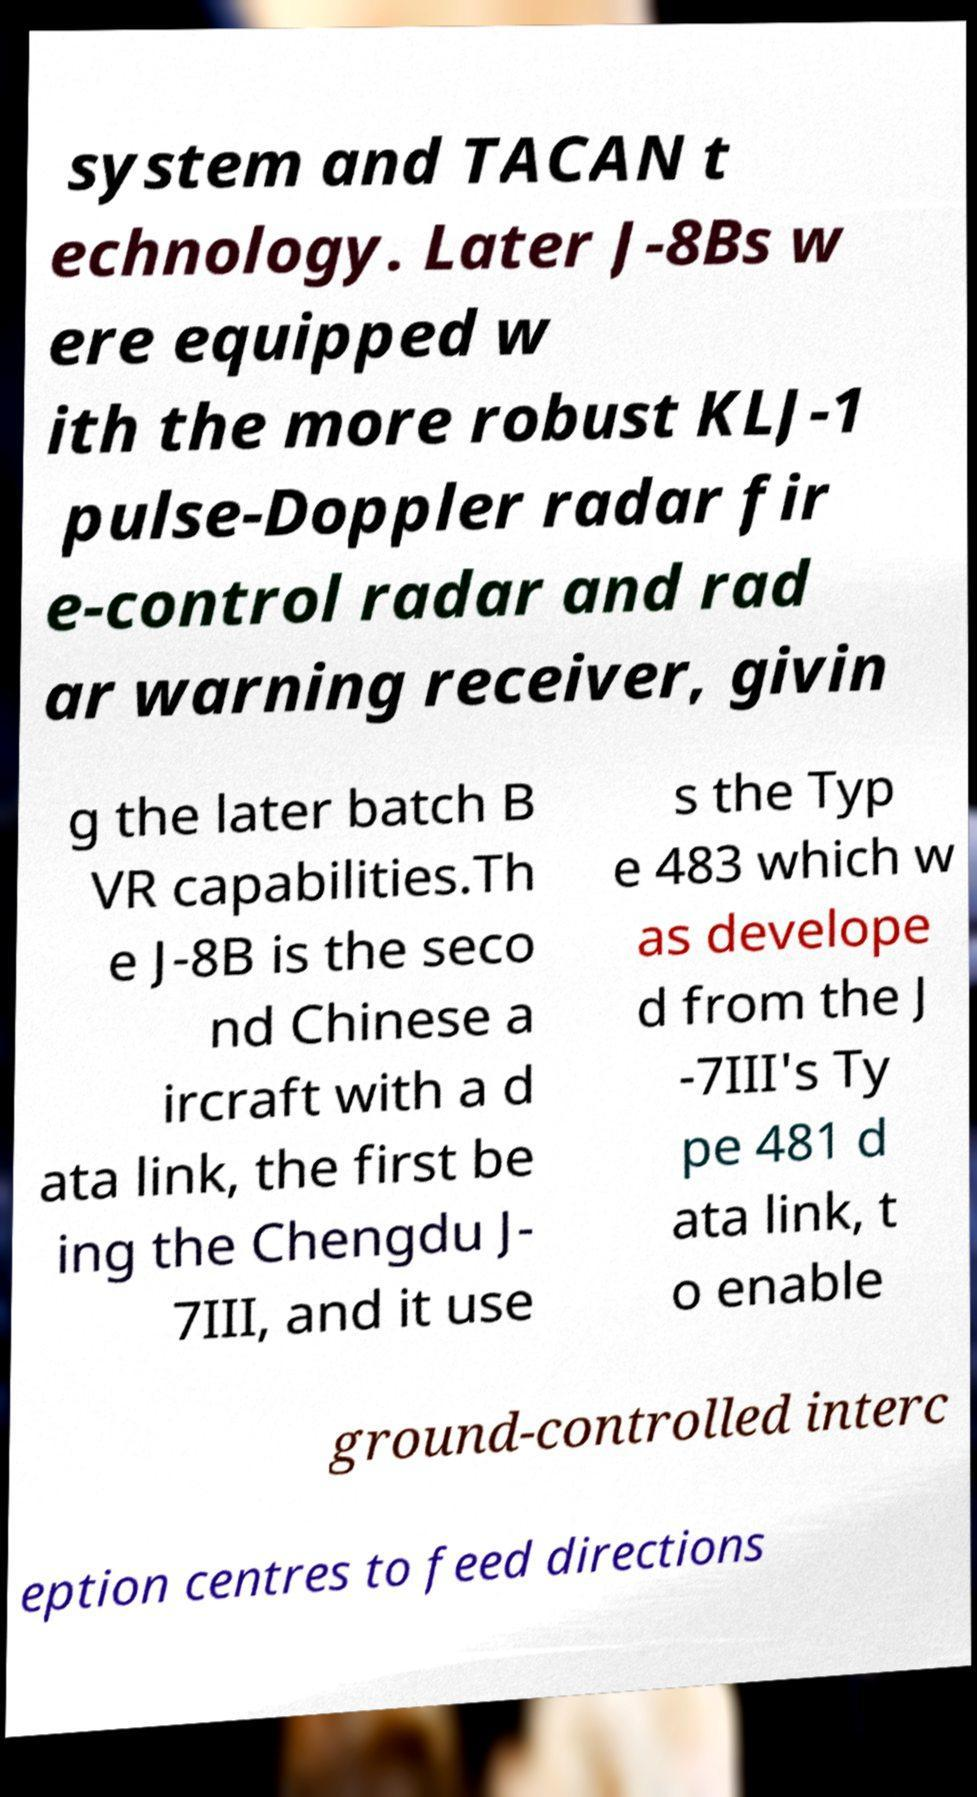What messages or text are displayed in this image? I need them in a readable, typed format. system and TACAN t echnology. Later J-8Bs w ere equipped w ith the more robust KLJ-1 pulse-Doppler radar fir e-control radar and rad ar warning receiver, givin g the later batch B VR capabilities.Th e J-8B is the seco nd Chinese a ircraft with a d ata link, the first be ing the Chengdu J- 7III, and it use s the Typ e 483 which w as develope d from the J -7III's Ty pe 481 d ata link, t o enable ground-controlled interc eption centres to feed directions 